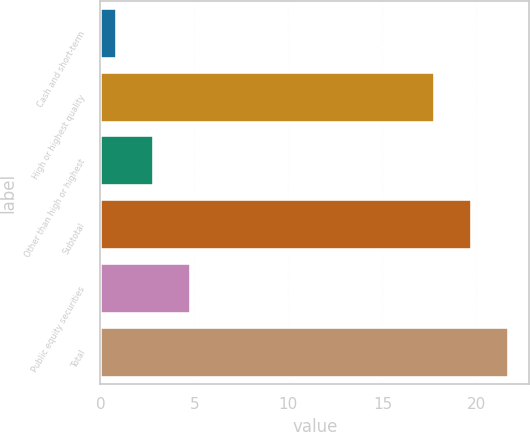Convert chart. <chart><loc_0><loc_0><loc_500><loc_500><bar_chart><fcel>Cash and short-term<fcel>High or highest quality<fcel>Other than high or highest<fcel>Subtotal<fcel>Public equity securities<fcel>Total<nl><fcel>0.9<fcel>17.8<fcel>2.86<fcel>19.76<fcel>4.82<fcel>21.72<nl></chart> 